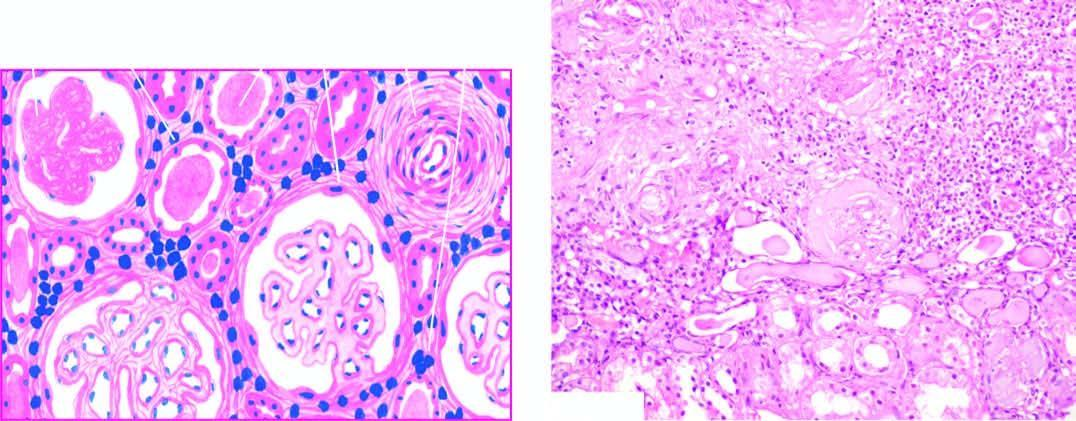what included are thick-walled?
Answer the question using a single word or phrase. Blood vessels 